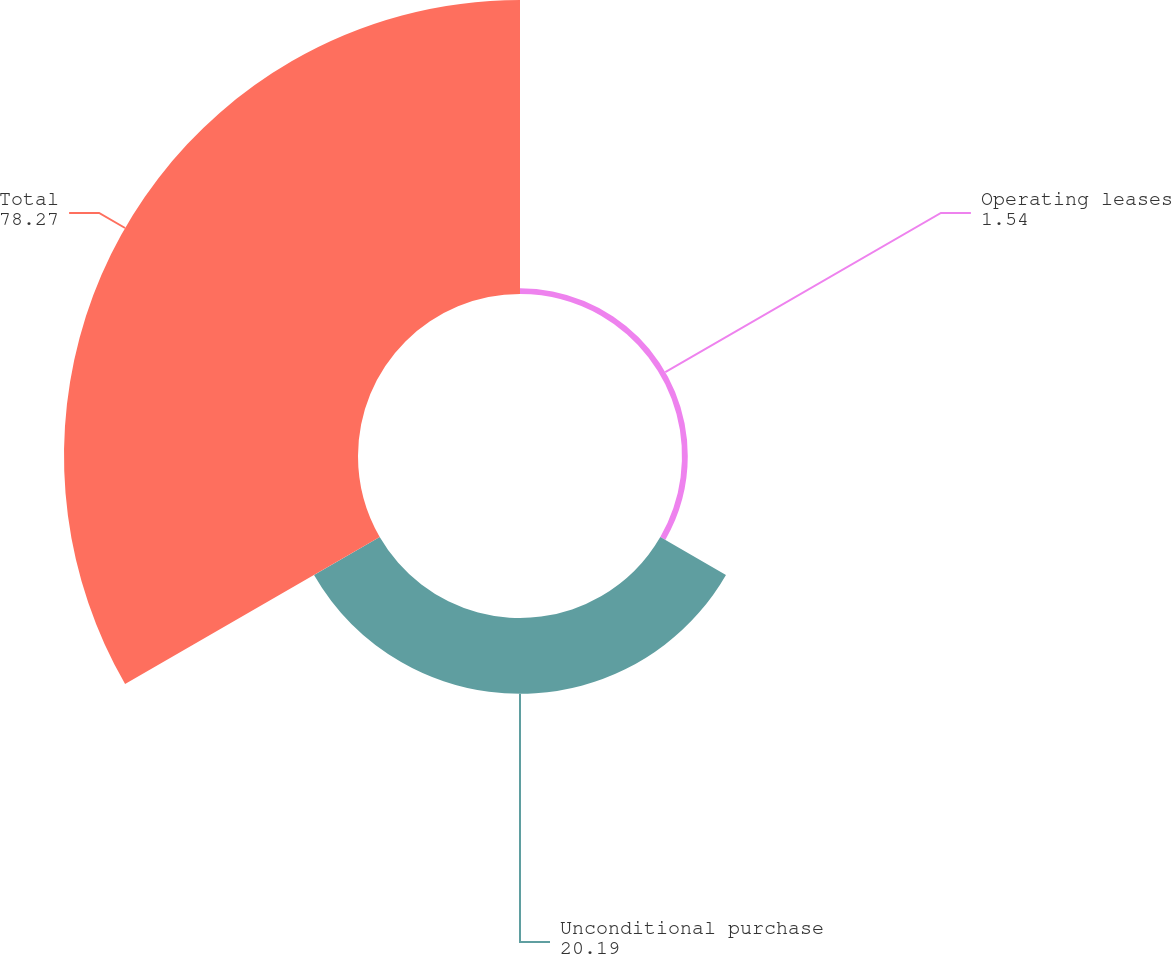Convert chart to OTSL. <chart><loc_0><loc_0><loc_500><loc_500><pie_chart><fcel>Operating leases<fcel>Unconditional purchase<fcel>Total<nl><fcel>1.54%<fcel>20.19%<fcel>78.27%<nl></chart> 